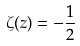<formula> <loc_0><loc_0><loc_500><loc_500>\zeta ( z ) = - \frac { 1 } { 2 }</formula> 